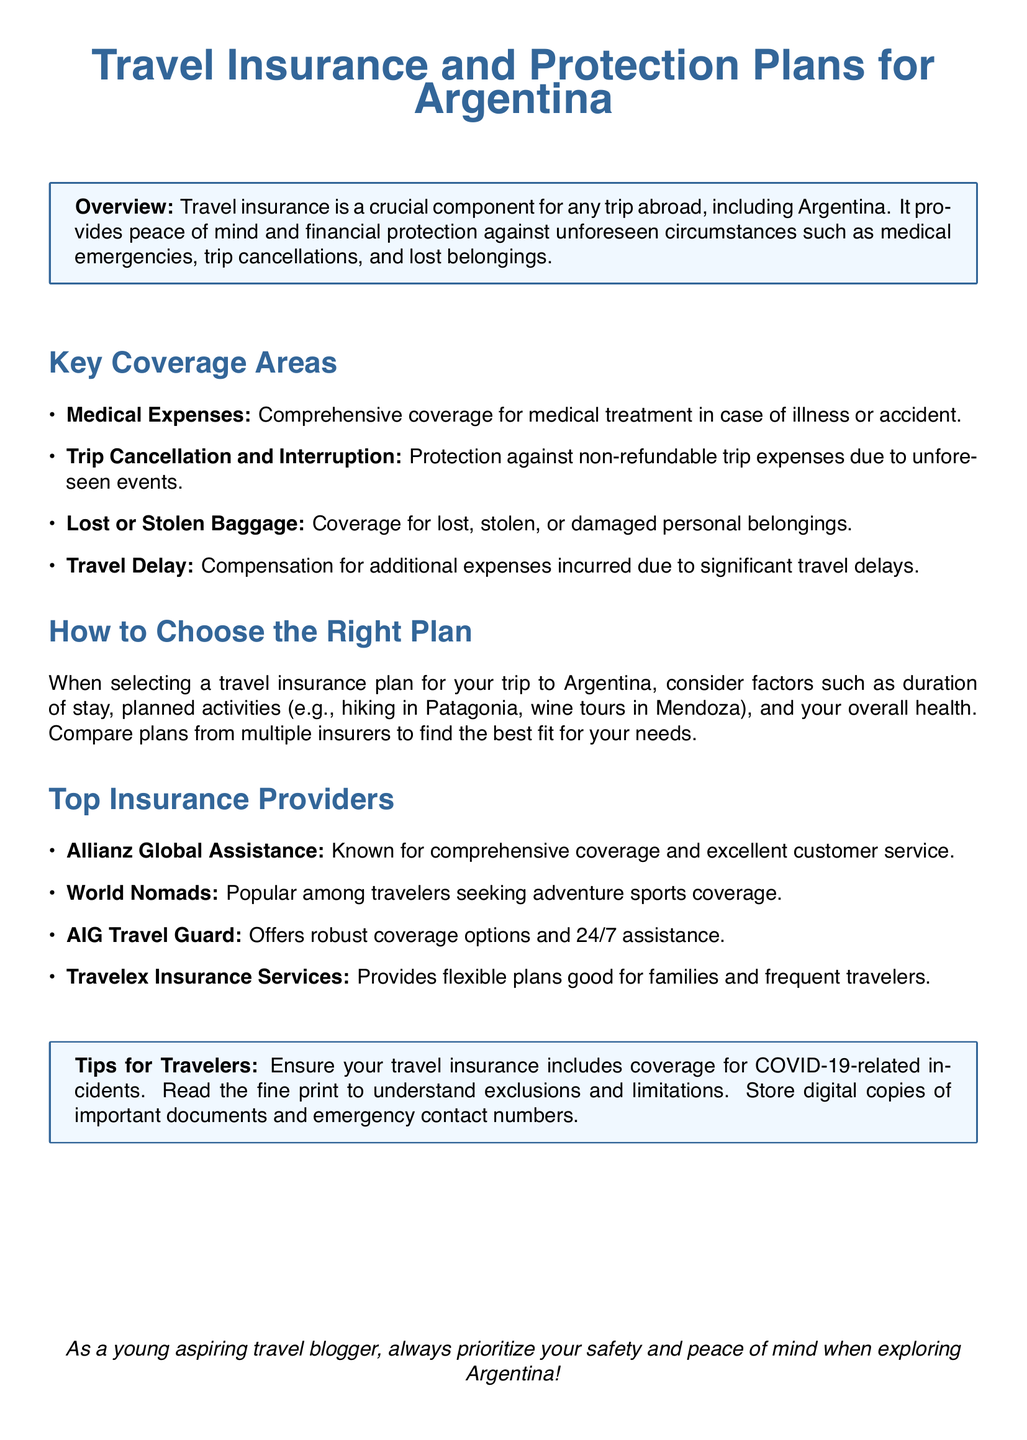what is the title of the document? The title of the document is presented at the top in a large font, centered.
Answer: Travel Insurance and Protection Plans for Argentina what is one key coverage area mentioned? The document lists multiple key coverage areas, showing one as an example.
Answer: Medical Expenses which insurance provider is known for adventure sports coverage? The document highlights a specific provider that is popular for a certain type of coverage.
Answer: World Nomads what should travelers ensure is included in their insurance? The document provides advice for travelers regarding specific incidents they should consider in their travel insurance.
Answer: COVID-19-related incidents how many insurance providers are listed in the document? The document enumerates a specific number of insurance providers.
Answer: Four 